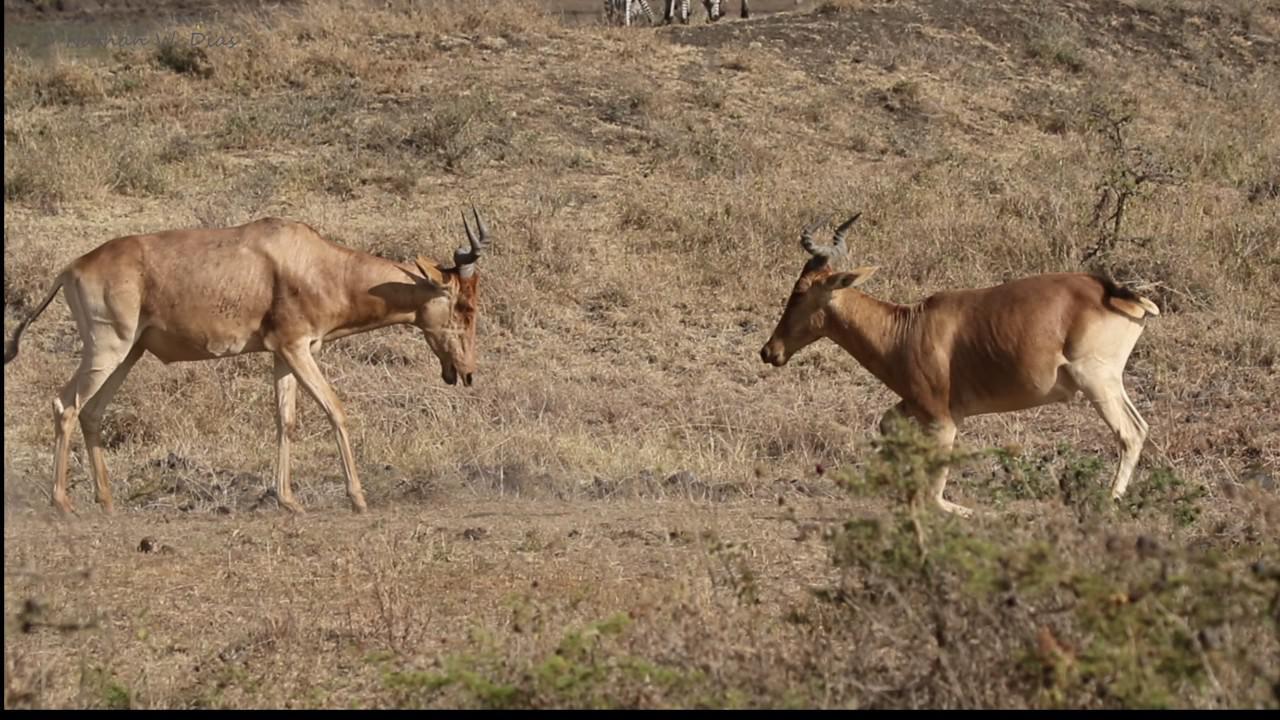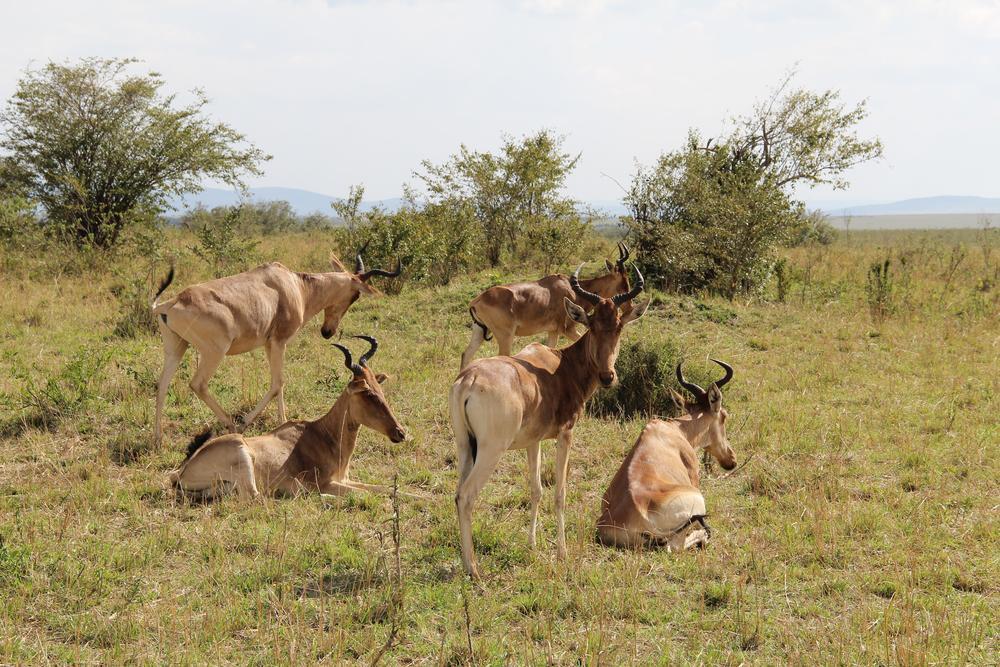The first image is the image on the left, the second image is the image on the right. For the images displayed, is the sentence "The right image contains at least twice as many hooved animals as the left image." factually correct? Answer yes or no. Yes. The first image is the image on the left, the second image is the image on the right. Evaluate the accuracy of this statement regarding the images: "There is a grand total of 4 animals between both pictures.". Is it true? Answer yes or no. No. 